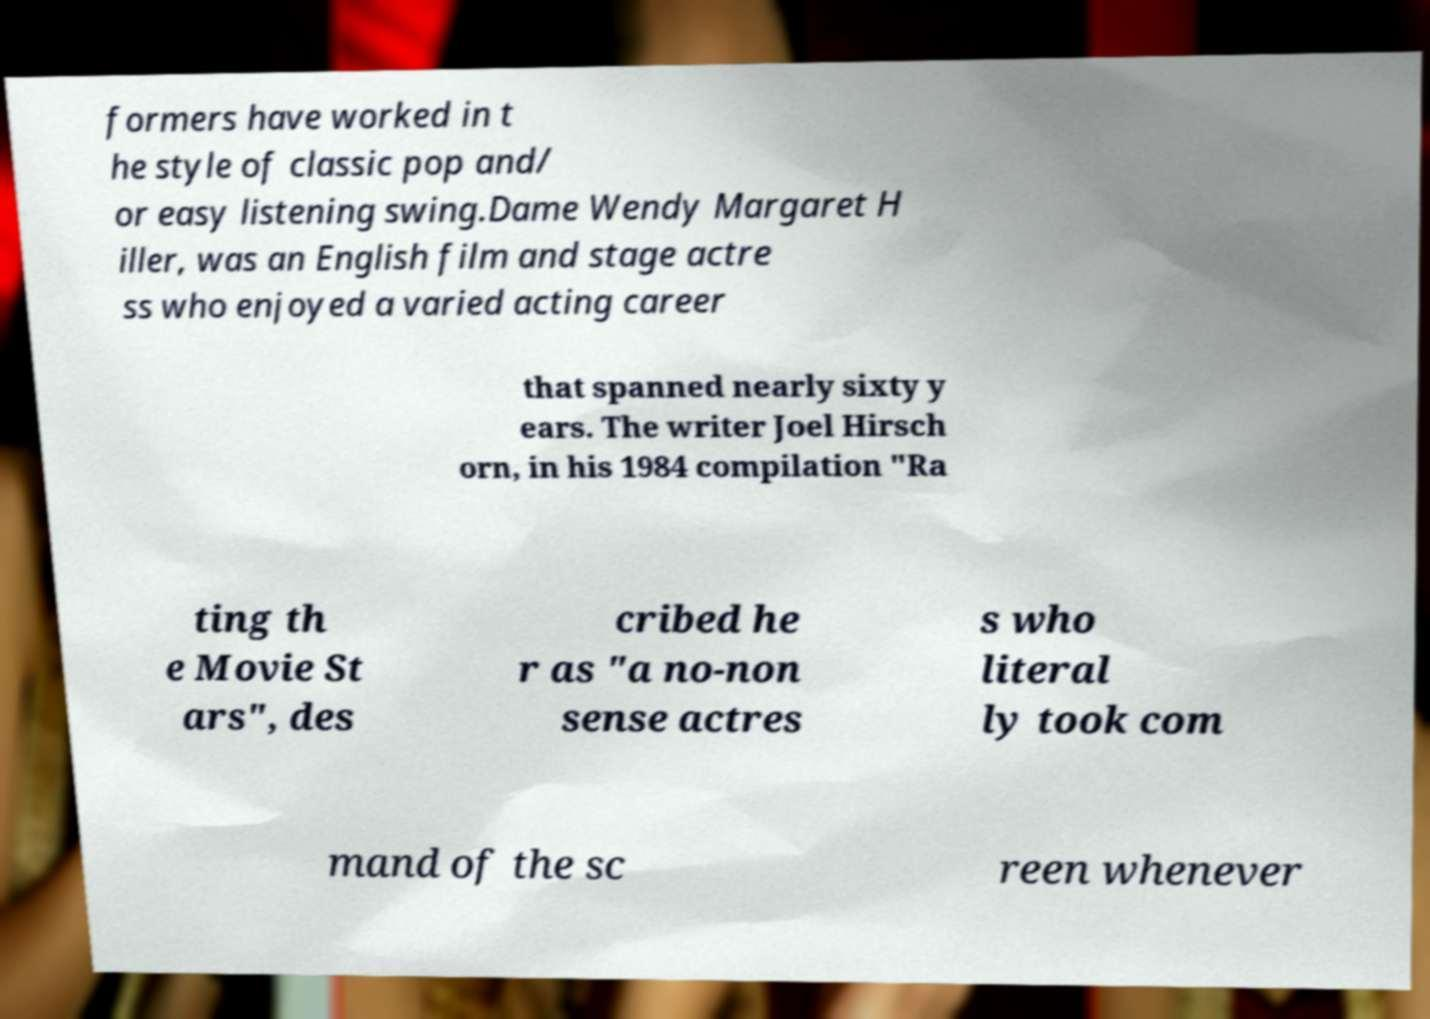Please read and relay the text visible in this image. What does it say? formers have worked in t he style of classic pop and/ or easy listening swing.Dame Wendy Margaret H iller, was an English film and stage actre ss who enjoyed a varied acting career that spanned nearly sixty y ears. The writer Joel Hirsch orn, in his 1984 compilation "Ra ting th e Movie St ars", des cribed he r as "a no-non sense actres s who literal ly took com mand of the sc reen whenever 